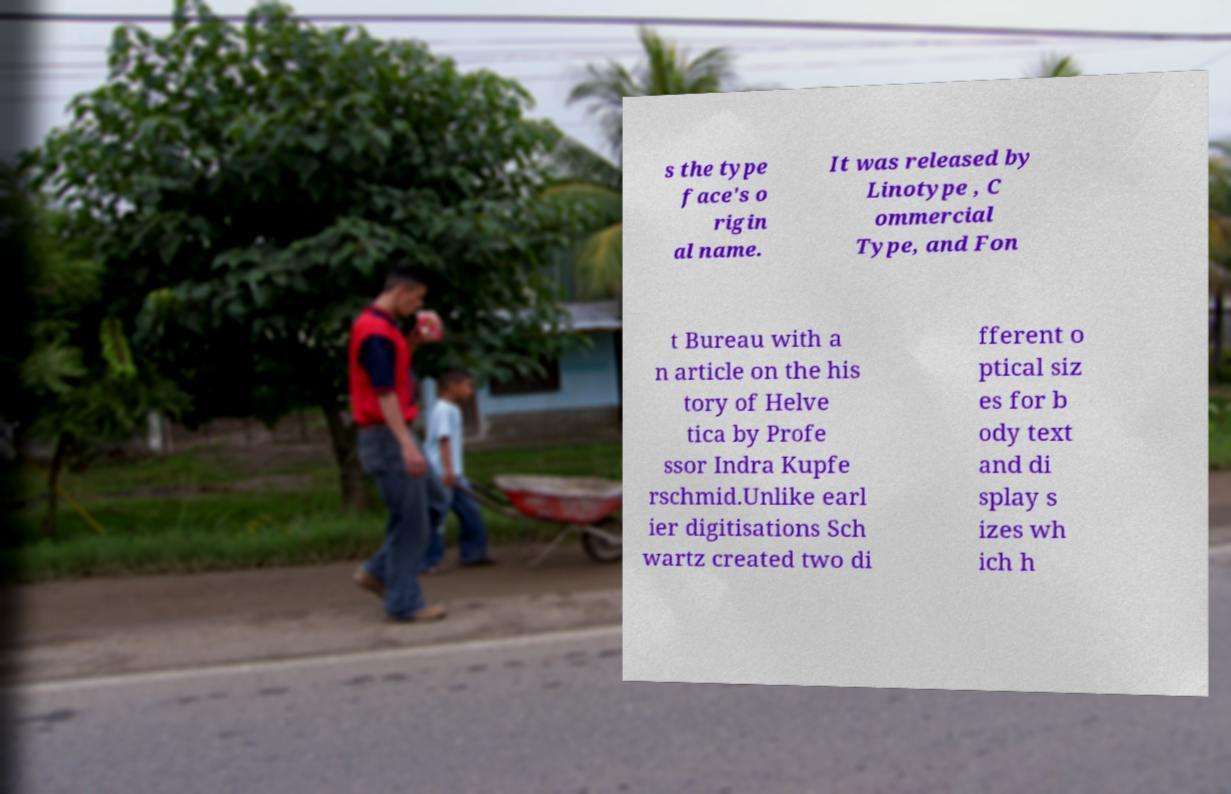Can you read and provide the text displayed in the image?This photo seems to have some interesting text. Can you extract and type it out for me? s the type face's o rigin al name. It was released by Linotype , C ommercial Type, and Fon t Bureau with a n article on the his tory of Helve tica by Profe ssor Indra Kupfe rschmid.Unlike earl ier digitisations Sch wartz created two di fferent o ptical siz es for b ody text and di splay s izes wh ich h 